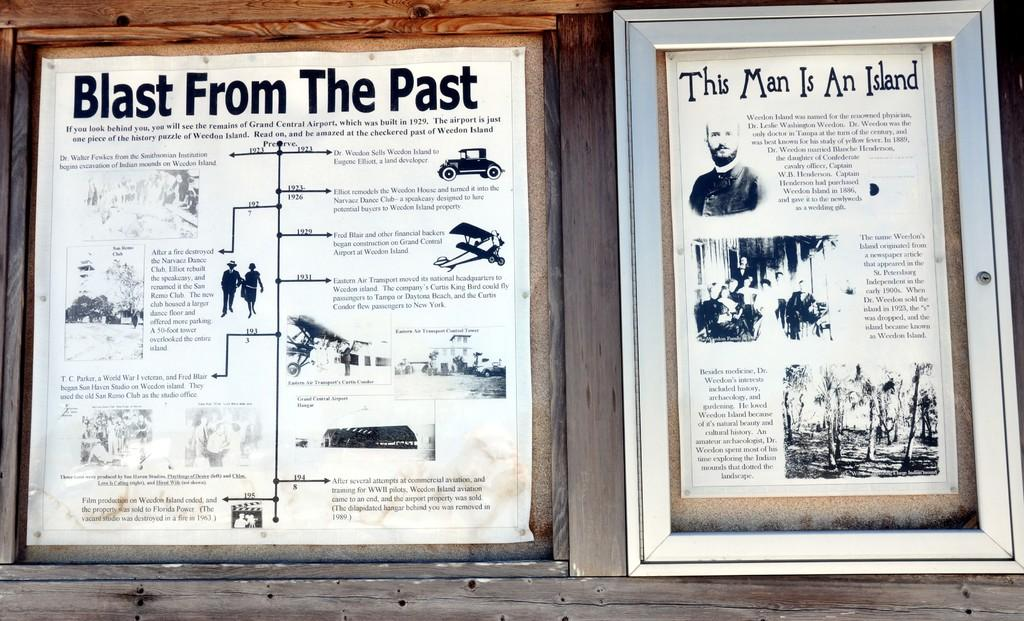<image>
Share a concise interpretation of the image provided. Historical news clippings about the accomplishments of several men in frames 